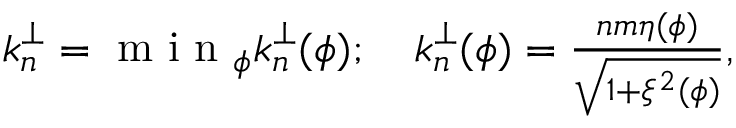<formula> <loc_0><loc_0><loc_500><loc_500>\begin{array} { r } { k _ { n } ^ { \perp } = \min _ { \phi } k _ { n } ^ { \perp } ( \phi ) ; \quad k _ { n } ^ { \perp } ( \phi ) = \frac { n m \eta ( \phi ) } { \sqrt { 1 + \xi ^ { 2 } ( \phi ) } } , } \end{array}</formula> 